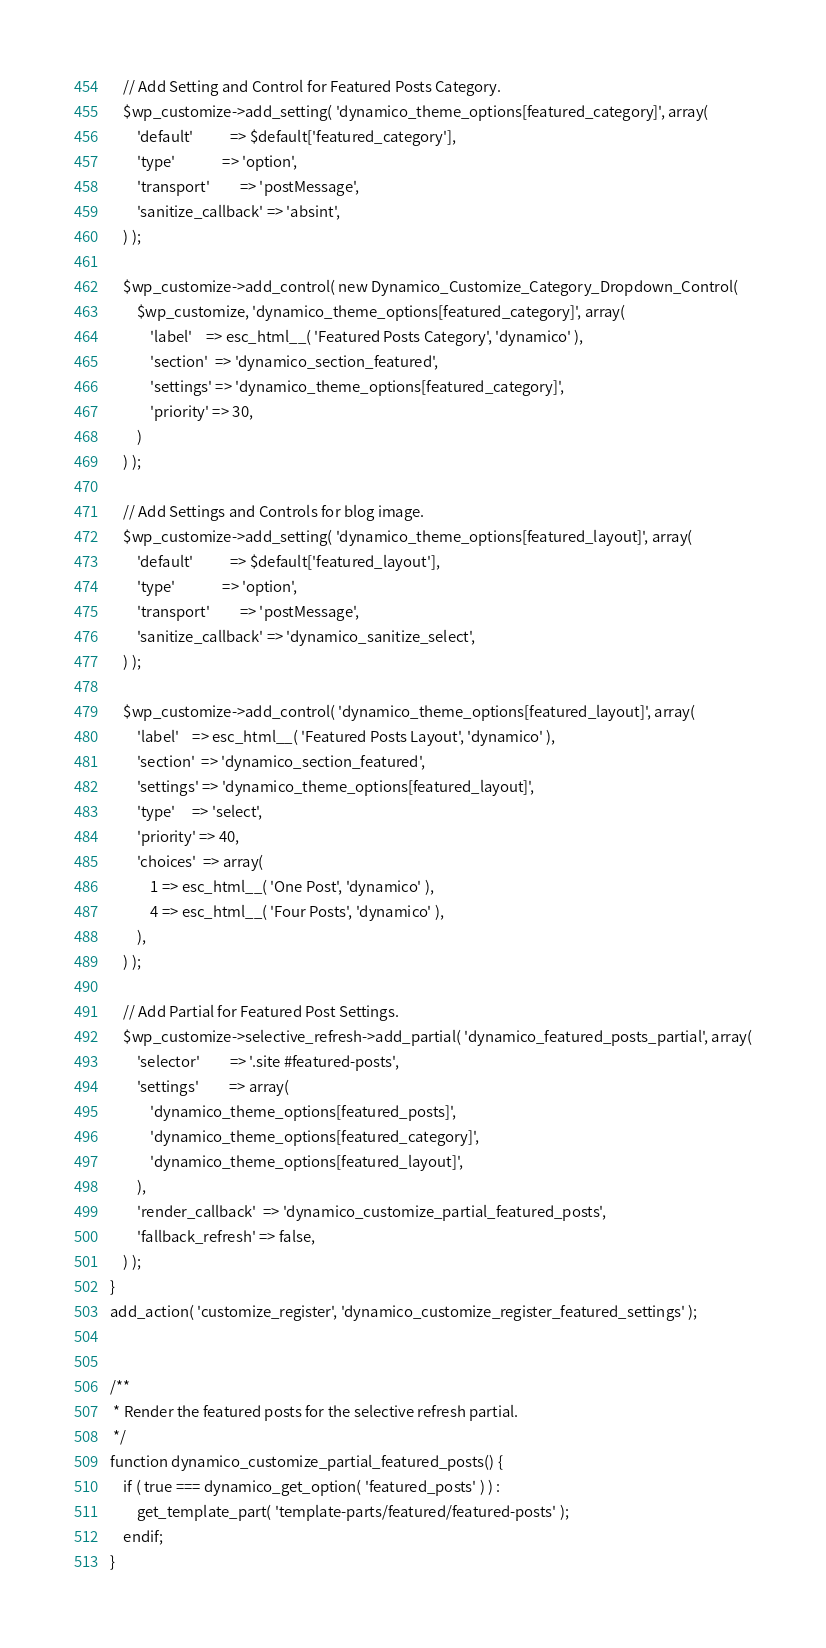<code> <loc_0><loc_0><loc_500><loc_500><_PHP_>
	// Add Setting and Control for Featured Posts Category.
	$wp_customize->add_setting( 'dynamico_theme_options[featured_category]', array(
		'default'           => $default['featured_category'],
		'type'              => 'option',
		'transport'         => 'postMessage',
		'sanitize_callback' => 'absint',
	) );

	$wp_customize->add_control( new Dynamico_Customize_Category_Dropdown_Control(
		$wp_customize, 'dynamico_theme_options[featured_category]', array(
			'label'    => esc_html__( 'Featured Posts Category', 'dynamico' ),
			'section'  => 'dynamico_section_featured',
			'settings' => 'dynamico_theme_options[featured_category]',
			'priority' => 30,
		)
	) );

	// Add Settings and Controls for blog image.
	$wp_customize->add_setting( 'dynamico_theme_options[featured_layout]', array(
		'default'           => $default['featured_layout'],
		'type'              => 'option',
		'transport'         => 'postMessage',
		'sanitize_callback' => 'dynamico_sanitize_select',
	) );

	$wp_customize->add_control( 'dynamico_theme_options[featured_layout]', array(
		'label'    => esc_html__( 'Featured Posts Layout', 'dynamico' ),
		'section'  => 'dynamico_section_featured',
		'settings' => 'dynamico_theme_options[featured_layout]',
		'type'     => 'select',
		'priority' => 40,
		'choices'  => array(
			1 => esc_html__( 'One Post', 'dynamico' ),
			4 => esc_html__( 'Four Posts', 'dynamico' ),
		),
	) );

	// Add Partial for Featured Post Settings.
	$wp_customize->selective_refresh->add_partial( 'dynamico_featured_posts_partial', array(
		'selector'         => '.site #featured-posts',
		'settings'         => array(
			'dynamico_theme_options[featured_posts]',
			'dynamico_theme_options[featured_category]',
			'dynamico_theme_options[featured_layout]',
		),
		'render_callback'  => 'dynamico_customize_partial_featured_posts',
		'fallback_refresh' => false,
	) );
}
add_action( 'customize_register', 'dynamico_customize_register_featured_settings' );


/**
 * Render the featured posts for the selective refresh partial.
 */
function dynamico_customize_partial_featured_posts() {
	if ( true === dynamico_get_option( 'featured_posts' ) ) :
		get_template_part( 'template-parts/featured/featured-posts' );
	endif;
}
</code> 